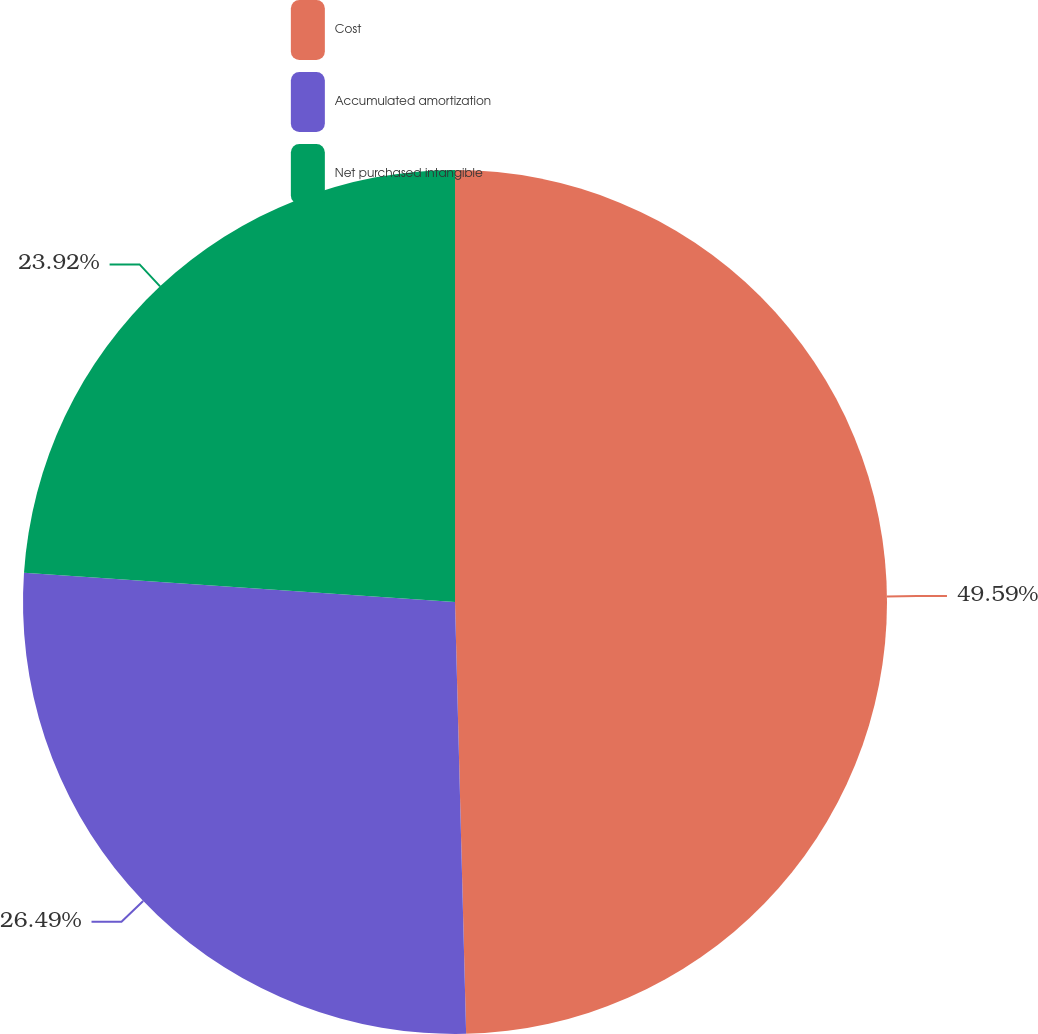Convert chart. <chart><loc_0><loc_0><loc_500><loc_500><pie_chart><fcel>Cost<fcel>Accumulated amortization<fcel>Net purchased intangible<nl><fcel>49.59%<fcel>26.49%<fcel>23.92%<nl></chart> 